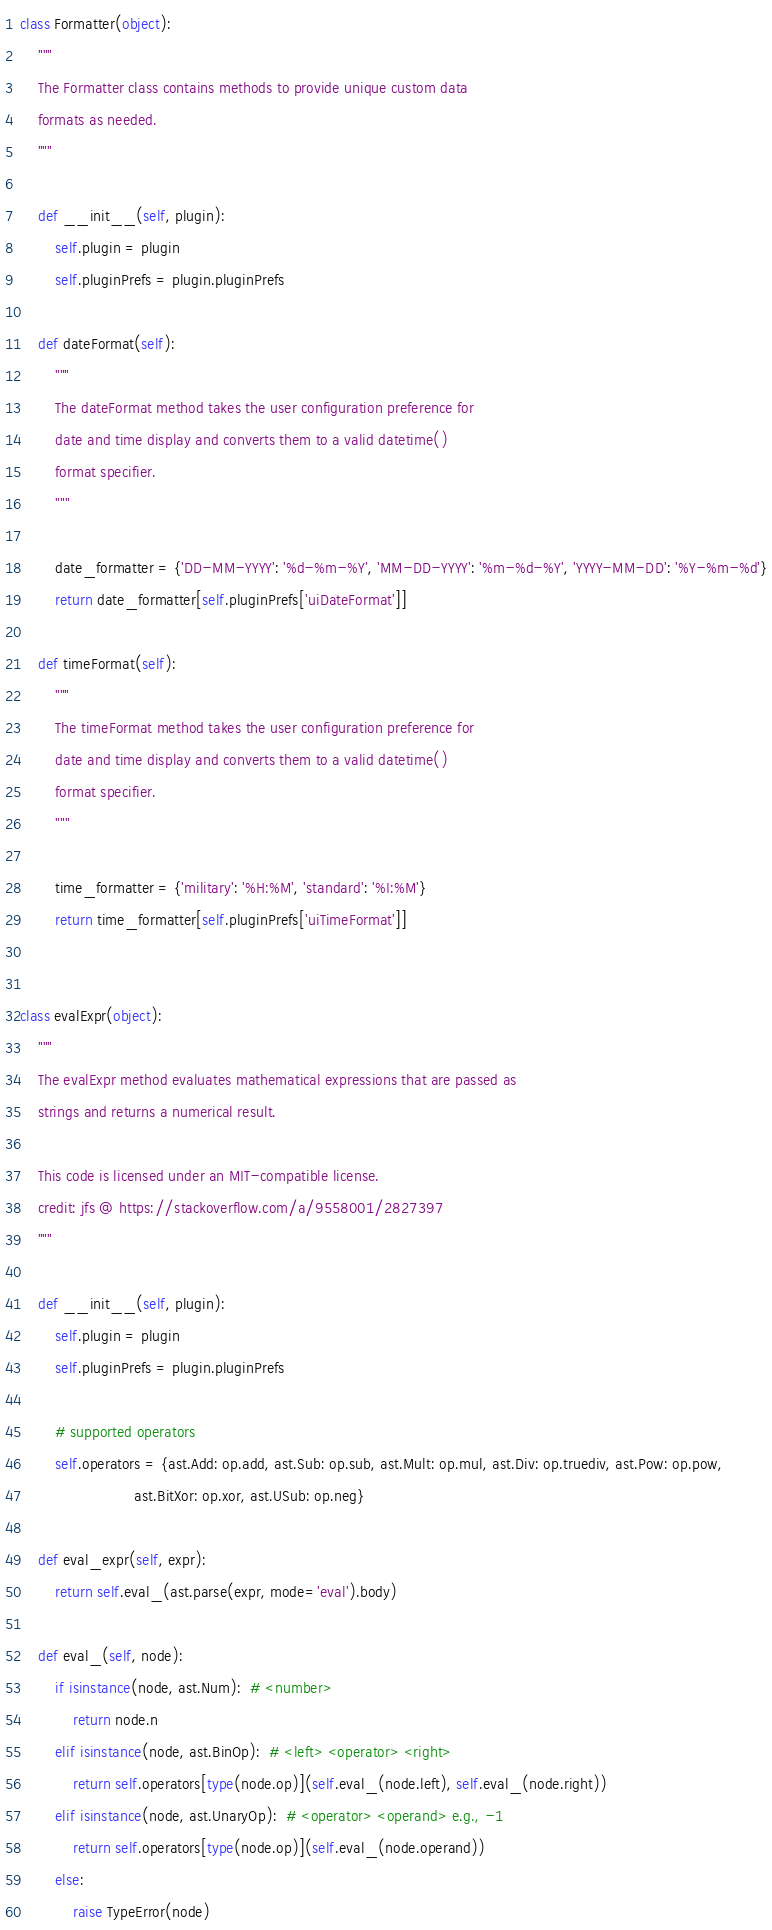Convert code to text. <code><loc_0><loc_0><loc_500><loc_500><_Python_>

class Formatter(object):
    """
    The Formatter class contains methods to provide unique custom data
    formats as needed.
    """

    def __init__(self, plugin):
        self.plugin = plugin
        self.pluginPrefs = plugin.pluginPrefs

    def dateFormat(self):
        """
        The dateFormat method takes the user configuration preference for
        date and time display and converts them to a valid datetime()
        format specifier.
        """

        date_formatter = {'DD-MM-YYYY': '%d-%m-%Y', 'MM-DD-YYYY': '%m-%d-%Y', 'YYYY-MM-DD': '%Y-%m-%d'}
        return date_formatter[self.pluginPrefs['uiDateFormat']]

    def timeFormat(self):
        """
        The timeFormat method takes the user configuration preference for
        date and time display and converts them to a valid datetime()
        format specifier.
        """

        time_formatter = {'military': '%H:%M', 'standard': '%I:%M'}
        return time_formatter[self.pluginPrefs['uiTimeFormat']]


class evalExpr(object):
    """
    The evalExpr method evaluates mathematical expressions that are passed as
    strings and returns a numerical result.

    This code is licensed under an MIT-compatible license.
    credit: jfs @ https://stackoverflow.com/a/9558001/2827397
    """

    def __init__(self, plugin):
        self.plugin = plugin
        self.pluginPrefs = plugin.pluginPrefs

        # supported operators
        self.operators = {ast.Add: op.add, ast.Sub: op.sub, ast.Mult: op.mul, ast.Div: op.truediv, ast.Pow: op.pow,
                          ast.BitXor: op.xor, ast.USub: op.neg}

    def eval_expr(self, expr):
        return self.eval_(ast.parse(expr, mode='eval').body)

    def eval_(self, node):
        if isinstance(node, ast.Num):  # <number>
            return node.n
        elif isinstance(node, ast.BinOp):  # <left> <operator> <right>
            return self.operators[type(node.op)](self.eval_(node.left), self.eval_(node.right))
        elif isinstance(node, ast.UnaryOp):  # <operator> <operand> e.g., -1
            return self.operators[type(node.op)](self.eval_(node.operand))
        else:
            raise TypeError(node)
</code> 